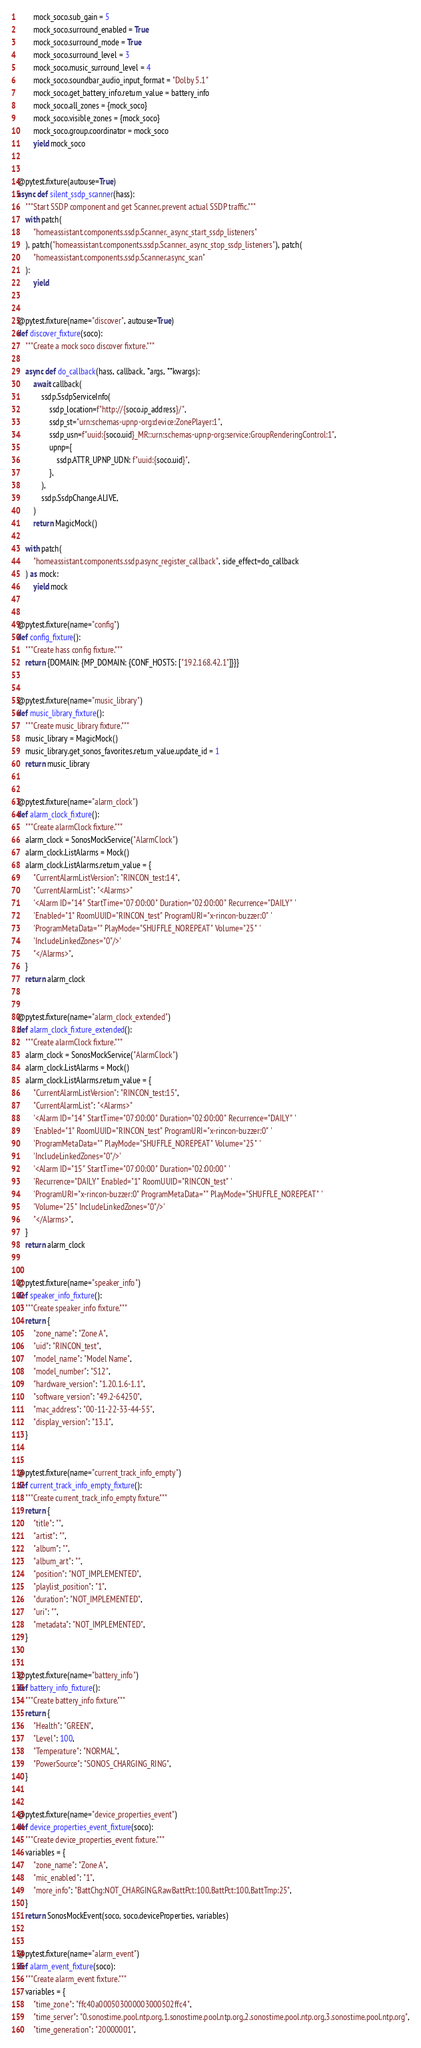Convert code to text. <code><loc_0><loc_0><loc_500><loc_500><_Python_>        mock_soco.sub_gain = 5
        mock_soco.surround_enabled = True
        mock_soco.surround_mode = True
        mock_soco.surround_level = 3
        mock_soco.music_surround_level = 4
        mock_soco.soundbar_audio_input_format = "Dolby 5.1"
        mock_soco.get_battery_info.return_value = battery_info
        mock_soco.all_zones = {mock_soco}
        mock_soco.visible_zones = {mock_soco}
        mock_soco.group.coordinator = mock_soco
        yield mock_soco


@pytest.fixture(autouse=True)
async def silent_ssdp_scanner(hass):
    """Start SSDP component and get Scanner, prevent actual SSDP traffic."""
    with patch(
        "homeassistant.components.ssdp.Scanner._async_start_ssdp_listeners"
    ), patch("homeassistant.components.ssdp.Scanner._async_stop_ssdp_listeners"), patch(
        "homeassistant.components.ssdp.Scanner.async_scan"
    ):
        yield


@pytest.fixture(name="discover", autouse=True)
def discover_fixture(soco):
    """Create a mock soco discover fixture."""

    async def do_callback(hass, callback, *args, **kwargs):
        await callback(
            ssdp.SsdpServiceInfo(
                ssdp_location=f"http://{soco.ip_address}/",
                ssdp_st="urn:schemas-upnp-org:device:ZonePlayer:1",
                ssdp_usn=f"uuid:{soco.uid}_MR::urn:schemas-upnp-org:service:GroupRenderingControl:1",
                upnp={
                    ssdp.ATTR_UPNP_UDN: f"uuid:{soco.uid}",
                },
            ),
            ssdp.SsdpChange.ALIVE,
        )
        return MagicMock()

    with patch(
        "homeassistant.components.ssdp.async_register_callback", side_effect=do_callback
    ) as mock:
        yield mock


@pytest.fixture(name="config")
def config_fixture():
    """Create hass config fixture."""
    return {DOMAIN: {MP_DOMAIN: {CONF_HOSTS: ["192.168.42.1"]}}}


@pytest.fixture(name="music_library")
def music_library_fixture():
    """Create music_library fixture."""
    music_library = MagicMock()
    music_library.get_sonos_favorites.return_value.update_id = 1
    return music_library


@pytest.fixture(name="alarm_clock")
def alarm_clock_fixture():
    """Create alarmClock fixture."""
    alarm_clock = SonosMockService("AlarmClock")
    alarm_clock.ListAlarms = Mock()
    alarm_clock.ListAlarms.return_value = {
        "CurrentAlarmListVersion": "RINCON_test:14",
        "CurrentAlarmList": "<Alarms>"
        '<Alarm ID="14" StartTime="07:00:00" Duration="02:00:00" Recurrence="DAILY" '
        'Enabled="1" RoomUUID="RINCON_test" ProgramURI="x-rincon-buzzer:0" '
        'ProgramMetaData="" PlayMode="SHUFFLE_NOREPEAT" Volume="25" '
        'IncludeLinkedZones="0"/>'
        "</Alarms>",
    }
    return alarm_clock


@pytest.fixture(name="alarm_clock_extended")
def alarm_clock_fixture_extended():
    """Create alarmClock fixture."""
    alarm_clock = SonosMockService("AlarmClock")
    alarm_clock.ListAlarms = Mock()
    alarm_clock.ListAlarms.return_value = {
        "CurrentAlarmListVersion": "RINCON_test:15",
        "CurrentAlarmList": "<Alarms>"
        '<Alarm ID="14" StartTime="07:00:00" Duration="02:00:00" Recurrence="DAILY" '
        'Enabled="1" RoomUUID="RINCON_test" ProgramURI="x-rincon-buzzer:0" '
        'ProgramMetaData="" PlayMode="SHUFFLE_NOREPEAT" Volume="25" '
        'IncludeLinkedZones="0"/>'
        '<Alarm ID="15" StartTime="07:00:00" Duration="02:00:00" '
        'Recurrence="DAILY" Enabled="1" RoomUUID="RINCON_test" '
        'ProgramURI="x-rincon-buzzer:0" ProgramMetaData="" PlayMode="SHUFFLE_NOREPEAT" '
        'Volume="25" IncludeLinkedZones="0"/>'
        "</Alarms>",
    }
    return alarm_clock


@pytest.fixture(name="speaker_info")
def speaker_info_fixture():
    """Create speaker_info fixture."""
    return {
        "zone_name": "Zone A",
        "uid": "RINCON_test",
        "model_name": "Model Name",
        "model_number": "S12",
        "hardware_version": "1.20.1.6-1.1",
        "software_version": "49.2-64250",
        "mac_address": "00-11-22-33-44-55",
        "display_version": "13.1",
    }


@pytest.fixture(name="current_track_info_empty")
def current_track_info_empty_fixture():
    """Create current_track_info_empty fixture."""
    return {
        "title": "",
        "artist": "",
        "album": "",
        "album_art": "",
        "position": "NOT_IMPLEMENTED",
        "playlist_position": "1",
        "duration": "NOT_IMPLEMENTED",
        "uri": "",
        "metadata": "NOT_IMPLEMENTED",
    }


@pytest.fixture(name="battery_info")
def battery_info_fixture():
    """Create battery_info fixture."""
    return {
        "Health": "GREEN",
        "Level": 100,
        "Temperature": "NORMAL",
        "PowerSource": "SONOS_CHARGING_RING",
    }


@pytest.fixture(name="device_properties_event")
def device_properties_event_fixture(soco):
    """Create device_properties_event fixture."""
    variables = {
        "zone_name": "Zone A",
        "mic_enabled": "1",
        "more_info": "BattChg:NOT_CHARGING,RawBattPct:100,BattPct:100,BattTmp:25",
    }
    return SonosMockEvent(soco, soco.deviceProperties, variables)


@pytest.fixture(name="alarm_event")
def alarm_event_fixture(soco):
    """Create alarm_event fixture."""
    variables = {
        "time_zone": "ffc40a000503000003000502ffc4",
        "time_server": "0.sonostime.pool.ntp.org,1.sonostime.pool.ntp.org,2.sonostime.pool.ntp.org,3.sonostime.pool.ntp.org",
        "time_generation": "20000001",</code> 